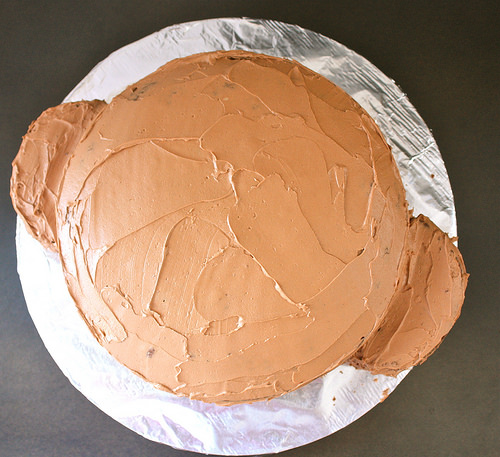<image>
Is the cake on the counter? Yes. Looking at the image, I can see the cake is positioned on top of the counter, with the counter providing support. 